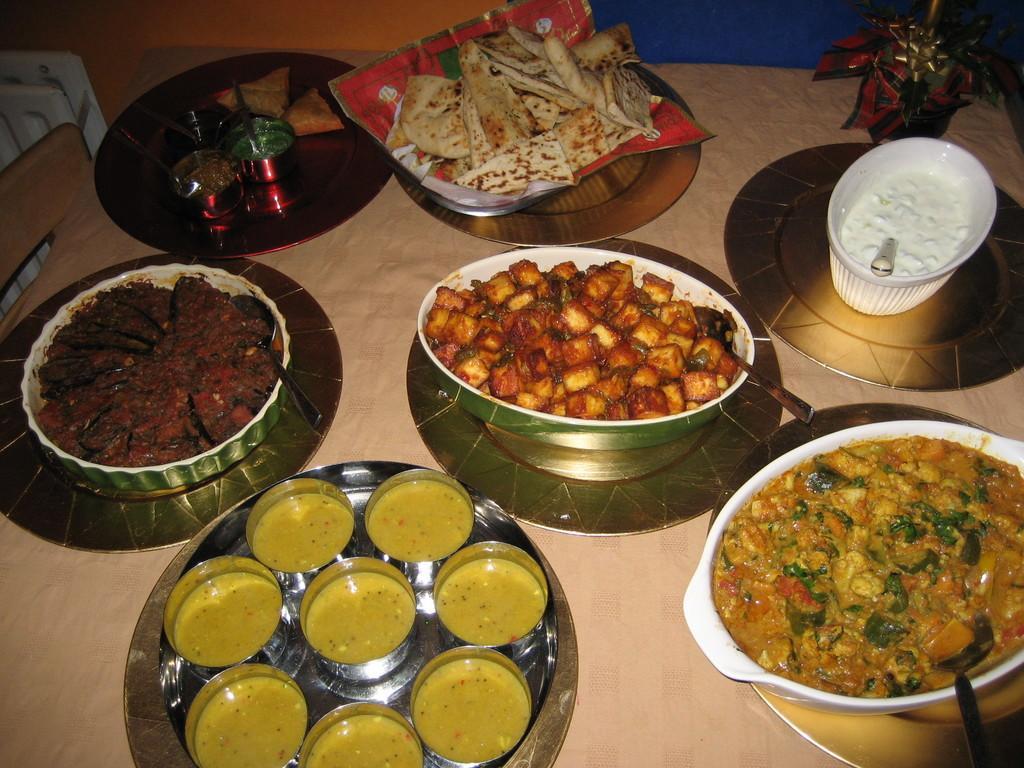Could you give a brief overview of what you see in this image? In this image we can see some food in the bowls which are placed on the table. We can also see some spoons and plates. At the top right we can see a decor. 